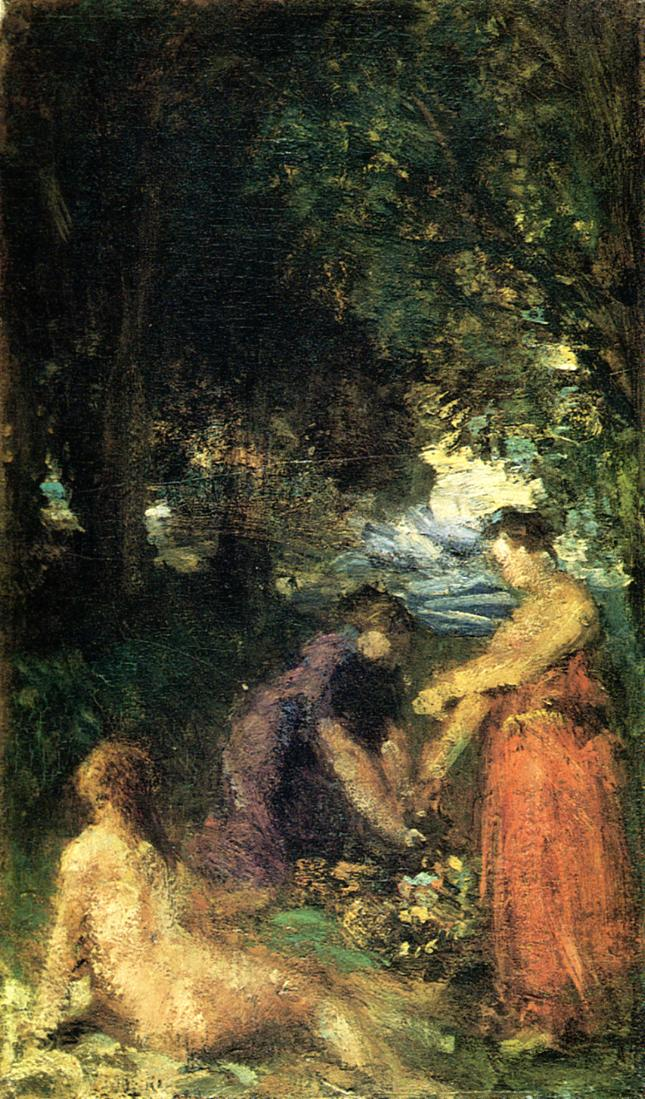If this picture could talk, what story would it tell? In the heart of an ancient woodland, a tale unfolds of lifelong companions who gather each season to celebrate their enduring friendship. Under the protective embrace of towering trees, these meetings have become a cherished tradition. Through the years, they’ve shared stories of love, loss, triumphs, and trials, all set against the backdrop of nature’s ever-changing canvas. On this clear day, the scent of wildflowers fills the air as they recount tales from the past, each memory painting a vibrant tapestry of shared history and timeless bonds. 